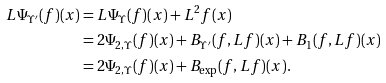<formula> <loc_0><loc_0><loc_500><loc_500>L \Psi _ { \Upsilon ^ { \prime } } ( f ) ( x ) & = L \Psi _ { \Upsilon } ( f ) ( x ) + L ^ { 2 } f ( x ) \\ & = 2 \Psi _ { 2 , \Upsilon } ( f ) ( x ) + B _ { \Upsilon ^ { \prime } } ( f , L f ) ( x ) + B _ { 1 } ( f , L f ) ( x ) \\ & = 2 \Psi _ { 2 , \Upsilon } ( f ) ( x ) + B _ { \exp } ( f , L f ) ( x ) .</formula> 